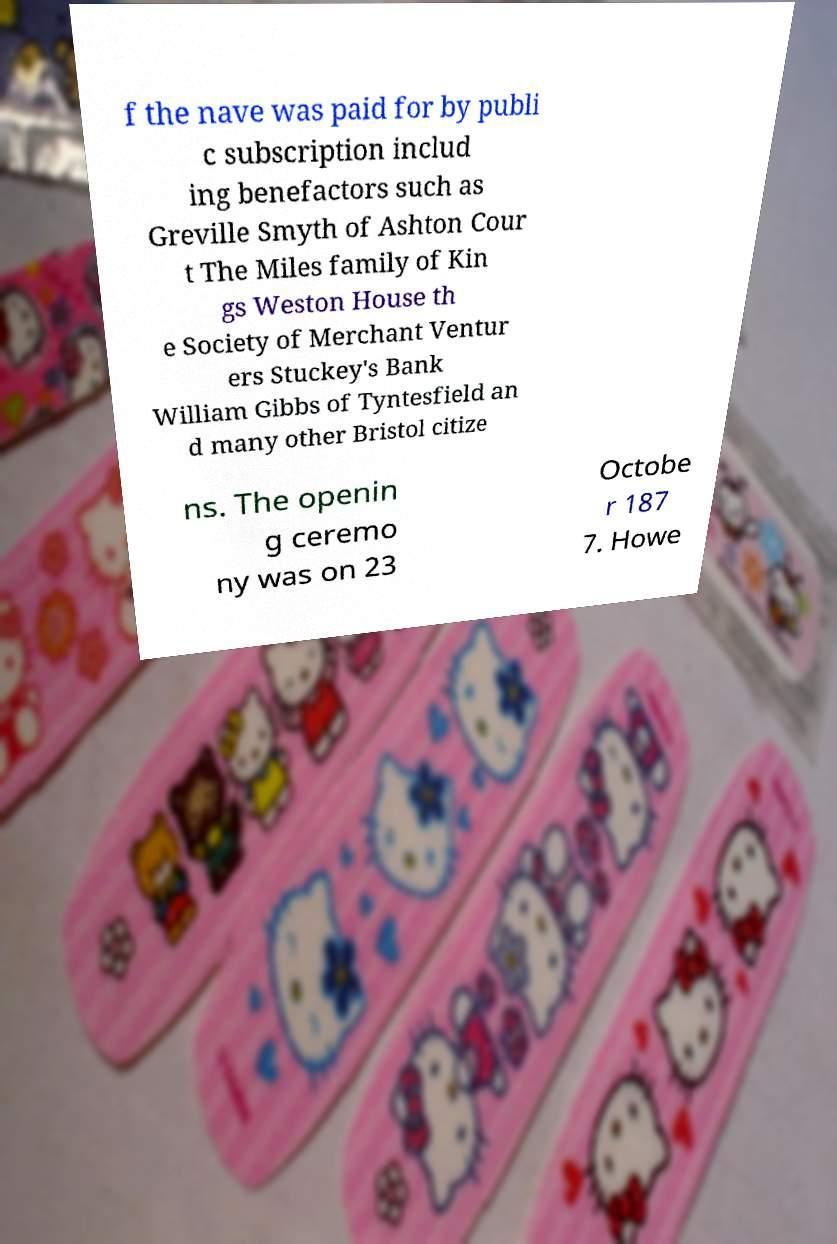Could you assist in decoding the text presented in this image and type it out clearly? f the nave was paid for by publi c subscription includ ing benefactors such as Greville Smyth of Ashton Cour t The Miles family of Kin gs Weston House th e Society of Merchant Ventur ers Stuckey's Bank William Gibbs of Tyntesfield an d many other Bristol citize ns. The openin g ceremo ny was on 23 Octobe r 187 7. Howe 